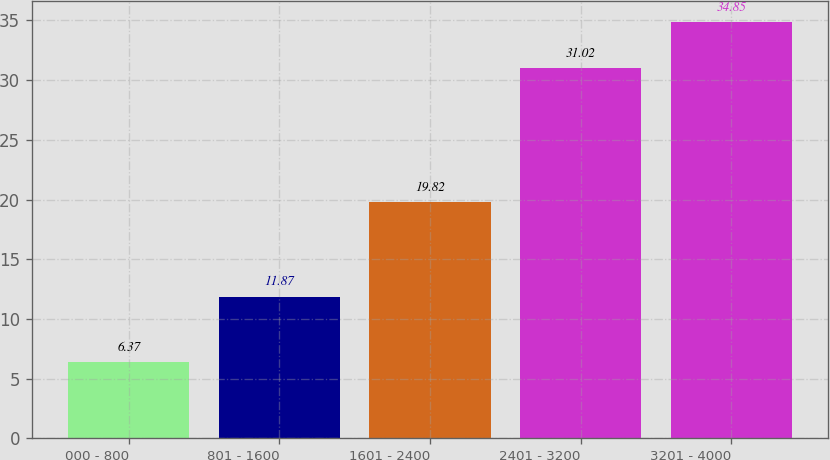<chart> <loc_0><loc_0><loc_500><loc_500><bar_chart><fcel>000 - 800<fcel>801 - 1600<fcel>1601 - 2400<fcel>2401 - 3200<fcel>3201 - 4000<nl><fcel>6.37<fcel>11.87<fcel>19.82<fcel>31.02<fcel>34.85<nl></chart> 